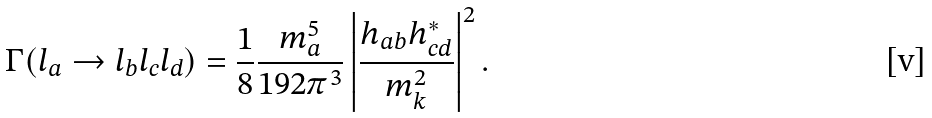Convert formula to latex. <formula><loc_0><loc_0><loc_500><loc_500>\Gamma ( l _ { a } \rightarrow l _ { b } l _ { c } l _ { d } ) = \frac { 1 } { 8 } \frac { m _ { a } ^ { 5 } } { 1 9 2 \pi ^ { 3 } } \left | \frac { h _ { a b } h _ { c d } ^ { * } } { m _ { k } ^ { 2 } } \right | ^ { 2 } .</formula> 